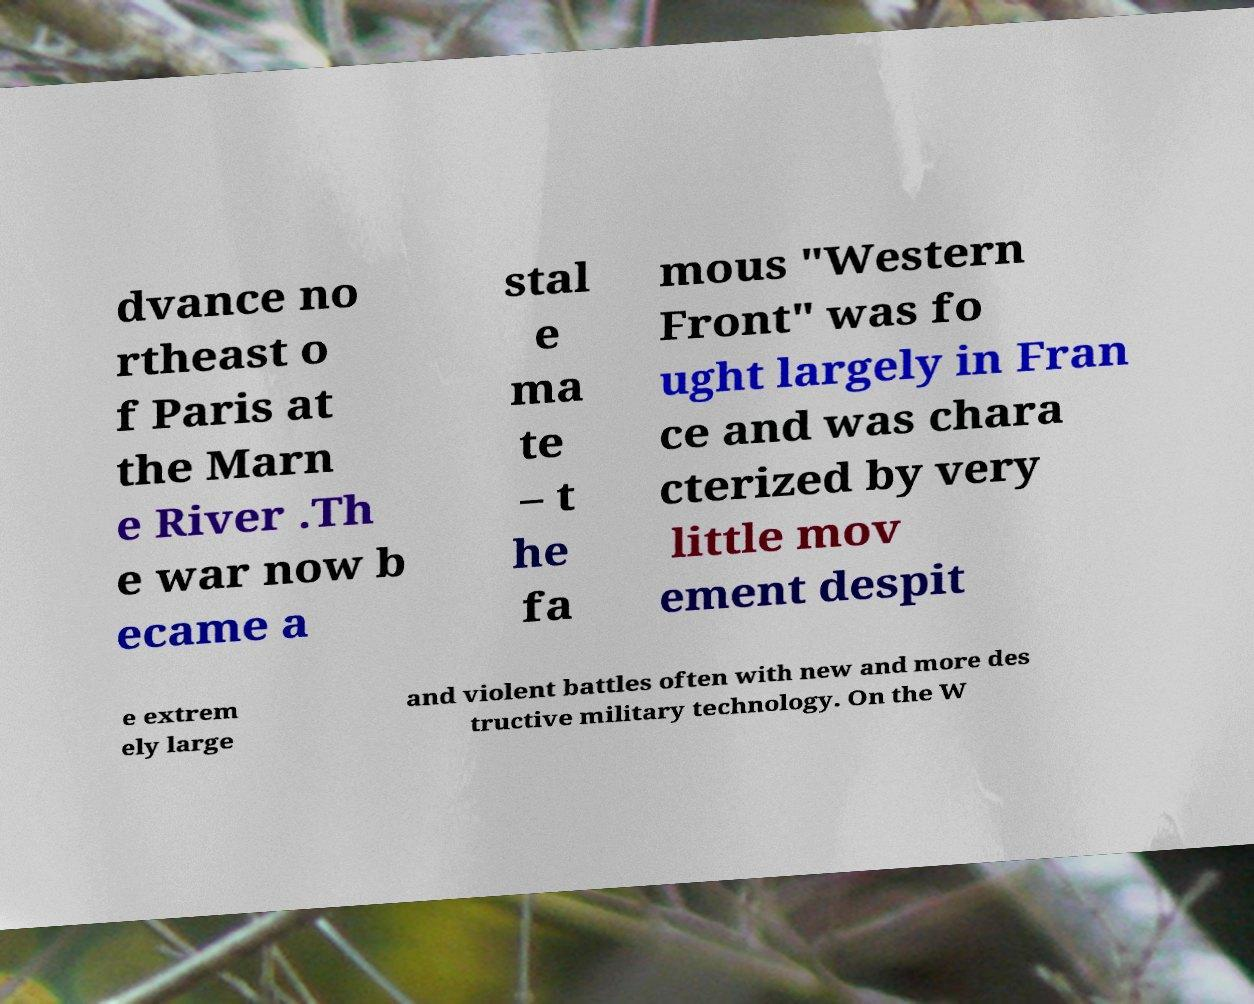Could you assist in decoding the text presented in this image and type it out clearly? dvance no rtheast o f Paris at the Marn e River .Th e war now b ecame a stal e ma te – t he fa mous "Western Front" was fo ught largely in Fran ce and was chara cterized by very little mov ement despit e extrem ely large and violent battles often with new and more des tructive military technology. On the W 